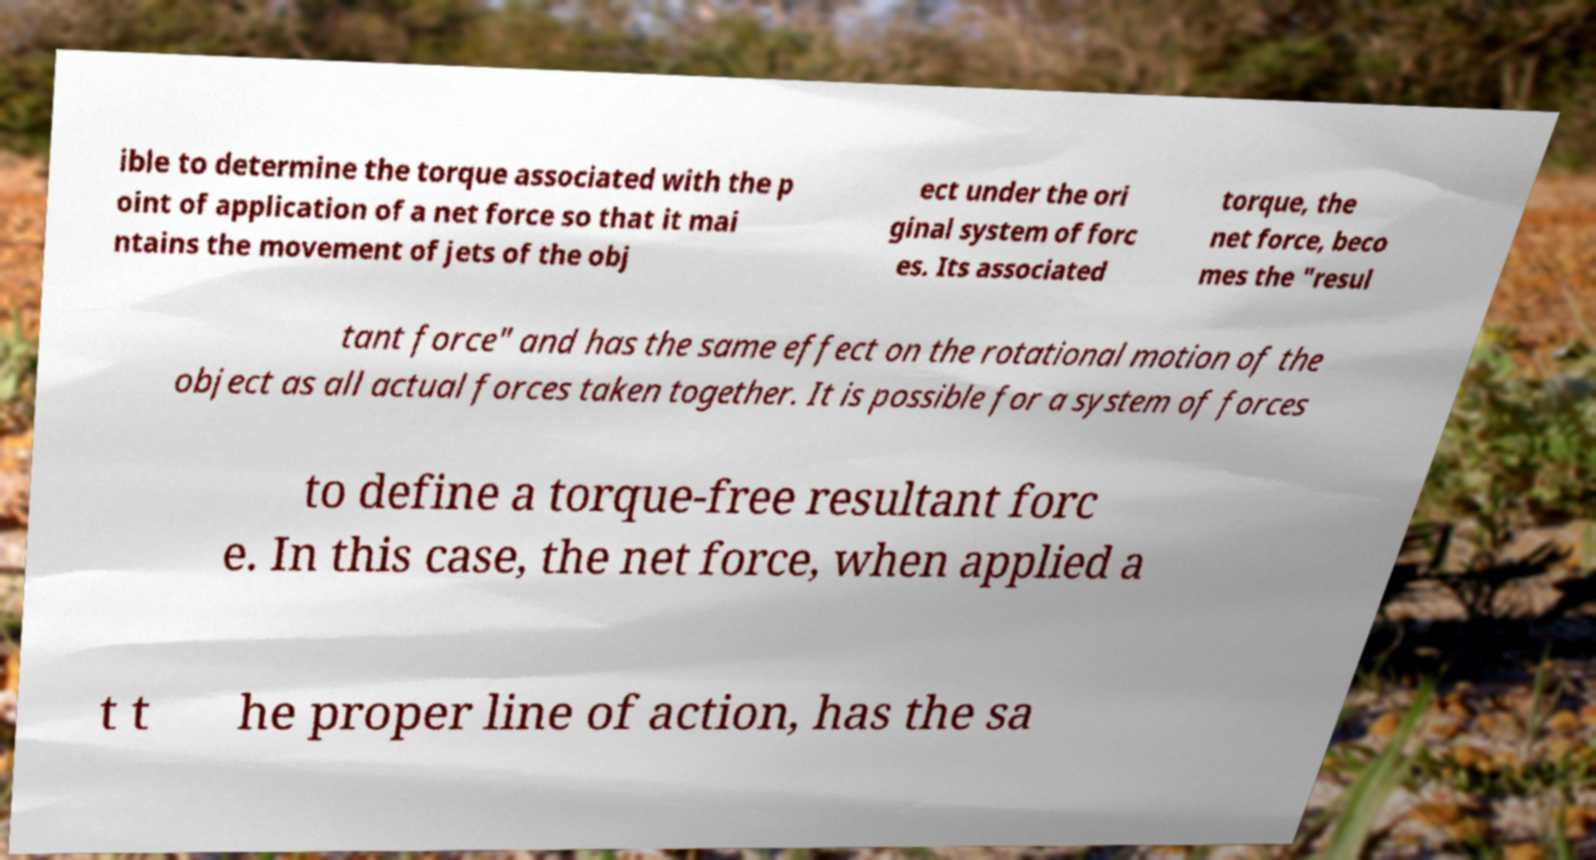For documentation purposes, I need the text within this image transcribed. Could you provide that? ible to determine the torque associated with the p oint of application of a net force so that it mai ntains the movement of jets of the obj ect under the ori ginal system of forc es. Its associated torque, the net force, beco mes the "resul tant force" and has the same effect on the rotational motion of the object as all actual forces taken together. It is possible for a system of forces to define a torque-free resultant forc e. In this case, the net force, when applied a t t he proper line of action, has the sa 